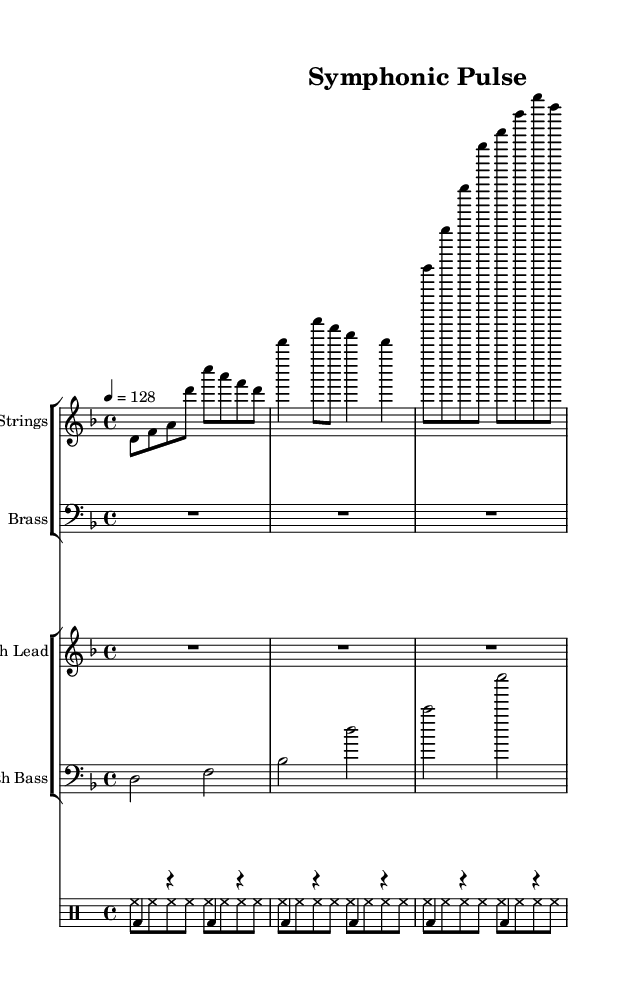What is the key signature of this music? The key signature is indicated by the presence of one flat, namely B flat, which means it is in D minor (or F major).
Answer: D minor What is the time signature of this piece? The time signature is found at the beginning of the score, represented as 4 over 4, indicating the piece has four beats per measure.
Answer: 4/4 What is the tempo marking of this composition? The tempo marking is indicated by the number 128, which signifies the beats per minute, shown above the staff as 4 = 128.
Answer: 128 How many measures are in the strings section? By counting the distinct rhythmic groupings, we see there are seven measures in the strings section.
Answer: 7 What type of instruments are included in the brass section? The brass section is labeled with a staff name; however, the notation includes rests only, indicating no active brass instruments in this piece.
Answer: None How does the bass drum pattern relate to the deep house genre? The bass drum plays on the downbeats, which is characteristic of deep house music's kick drum pattern that provides a solid rhythmic foundation.
Answer: Solid rhythmic foundation What is the primary rhythmic texture created by the hi-hat? The hi-hat plays an eighth-note pattern consistently throughout the measure, creating a driving rhythmic texture typical in electronic dance music.
Answer: Driving rhythmic texture 